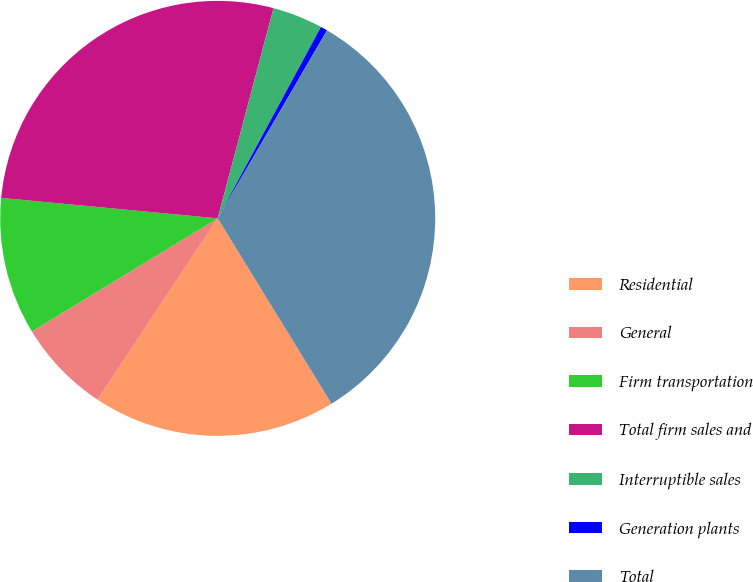Convert chart to OTSL. <chart><loc_0><loc_0><loc_500><loc_500><pie_chart><fcel>Residential<fcel>General<fcel>Firm transportation<fcel>Total firm sales and<fcel>Interruptible sales<fcel>Generation plants<fcel>Total<nl><fcel>18.08%<fcel>6.98%<fcel>10.21%<fcel>27.63%<fcel>3.74%<fcel>0.51%<fcel>32.85%<nl></chart> 